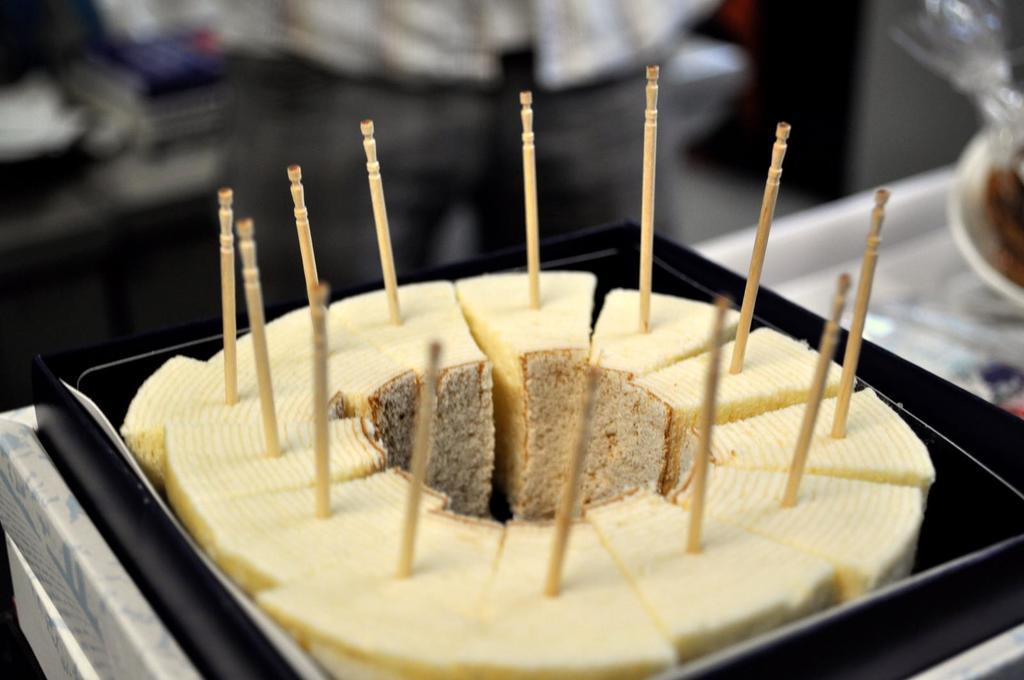What type of food can be seen in the image? There are pastries in the image. How are the pastries arranged or displayed? The pastries are on a box. What is placed on top of the pastries? There are wooden sticks on top of the pastries. What is located beside the pastries? There is an object beside the pastries. Can you describe the background of the image? The background of the image is blurred. What type of wall is visible in the image? There is no wall visible in the image; the background is blurred. How does the cup affect the taste of the pastries in the image? There is no cup present in the image, so it cannot affect the taste of the pastries. 